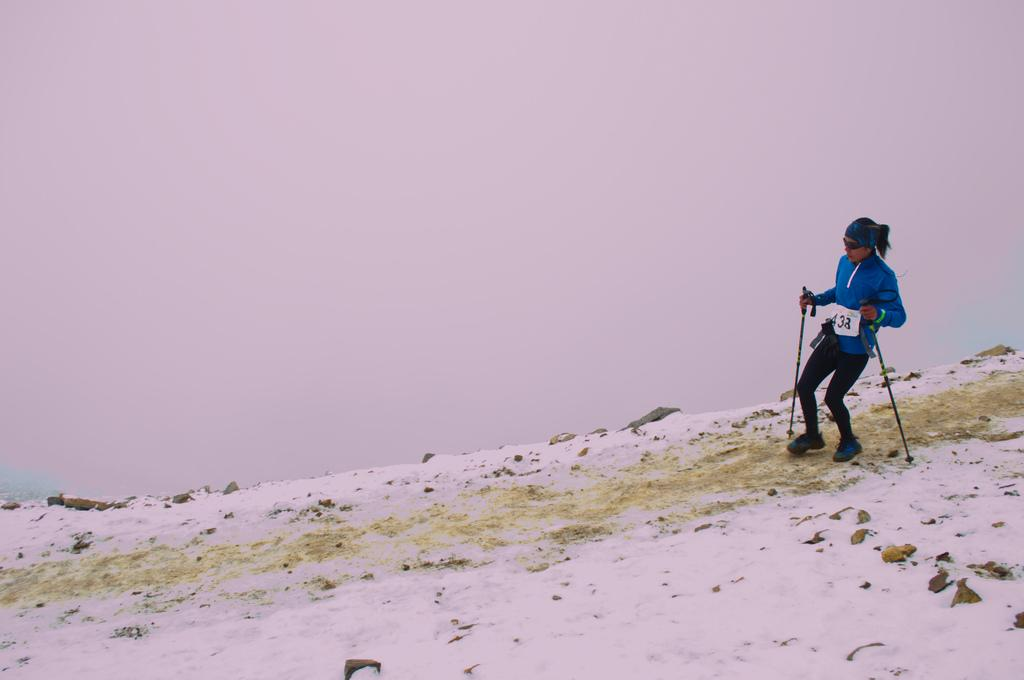What is the main subject of the image? There is a person in the image. What is the person holding in the image? The person is holding sticks. What is the person's posture in the image? The person is standing. What can be seen on the ground in the image? There is snow on the ground. What is visible in the background of the image? The sky is visible in the background. How does the person compare their sticks to the game in the image? There is no game present in the image, and the person is not making any comparisons. 